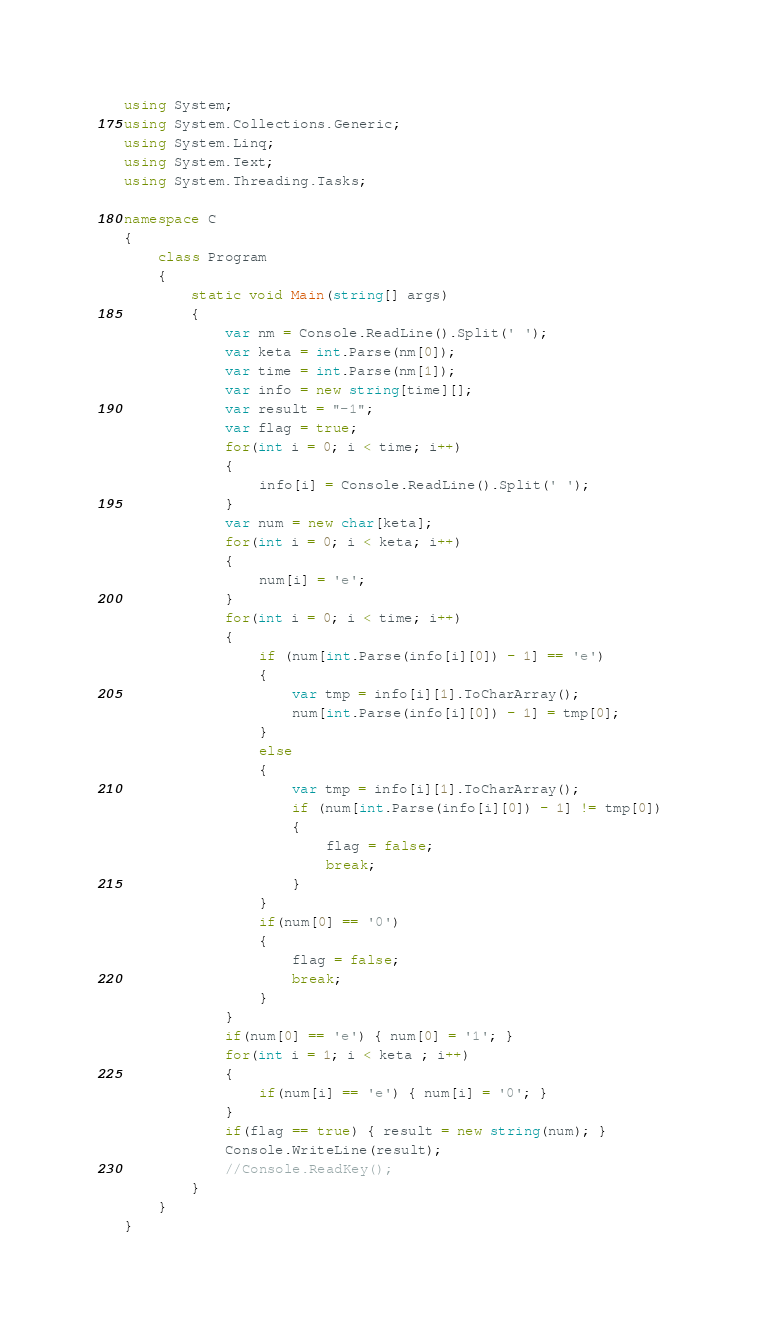<code> <loc_0><loc_0><loc_500><loc_500><_C#_>using System;
using System.Collections.Generic;
using System.Linq;
using System.Text;
using System.Threading.Tasks;

namespace C
{
    class Program
    {
        static void Main(string[] args)
        {
            var nm = Console.ReadLine().Split(' ');
            var keta = int.Parse(nm[0]);
            var time = int.Parse(nm[1]);
            var info = new string[time][];
            var result = "-1";
            var flag = true;
            for(int i = 0; i < time; i++)
            {
                info[i] = Console.ReadLine().Split(' ');
            }
            var num = new char[keta];
            for(int i = 0; i < keta; i++)
            {
                num[i] = 'e';
            }
            for(int i = 0; i < time; i++)
            {
                if (num[int.Parse(info[i][0]) - 1] == 'e')
                {
                    var tmp = info[i][1].ToCharArray();
                    num[int.Parse(info[i][0]) - 1] = tmp[0];
                }
                else
                {
                    var tmp = info[i][1].ToCharArray();
                    if (num[int.Parse(info[i][0]) - 1] != tmp[0])
                    {
                        flag = false;
                        break;
                    }
                }
                if(num[0] == '0')
                {
                    flag = false;
                    break;
                }
            }
            if(num[0] == 'e') { num[0] = '1'; }
            for(int i = 1; i < keta ; i++)
            {
                if(num[i] == 'e') { num[i] = '0'; }
            }
            if(flag == true) { result = new string(num); }
            Console.WriteLine(result);
            //Console.ReadKey();
        }
    }
}</code> 